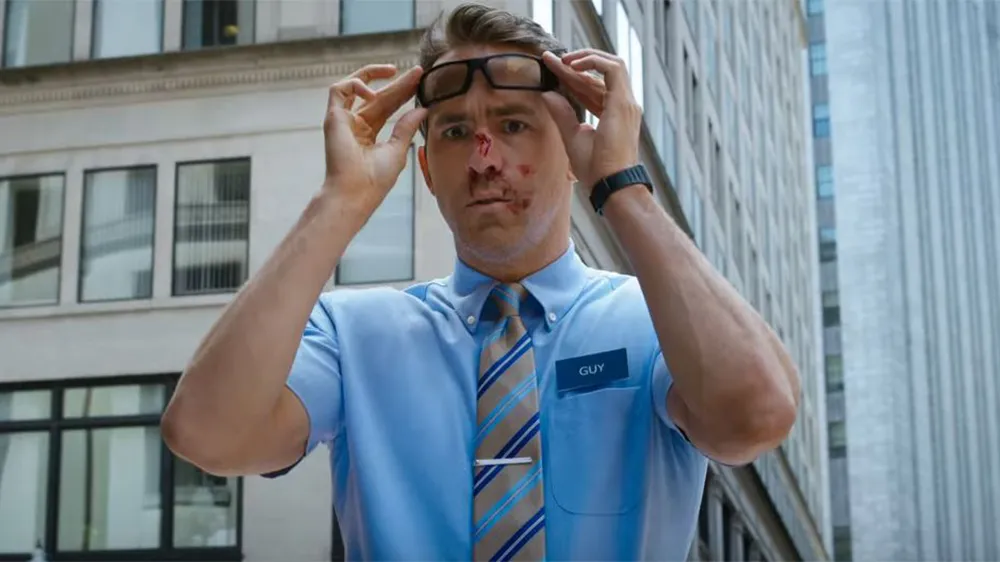What role might this character play in his narrative based on his attire and expression? Based on his attire, which resembles a service or retail uniform, and his bewildered expression, the character likely represents an everyman thrust into unusual, perhaps comedic or thrilling, circumstances beyond his normal routine. 